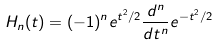<formula> <loc_0><loc_0><loc_500><loc_500>H _ { n } ( t ) = ( - 1 ) ^ { n } e ^ { t ^ { 2 } / 2 } \frac { d ^ { n } } { d t ^ { n } } e ^ { - t ^ { 2 } / 2 }</formula> 